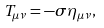<formula> <loc_0><loc_0><loc_500><loc_500>T _ { \mu \nu } = - \sigma \eta _ { \mu \nu } ,</formula> 